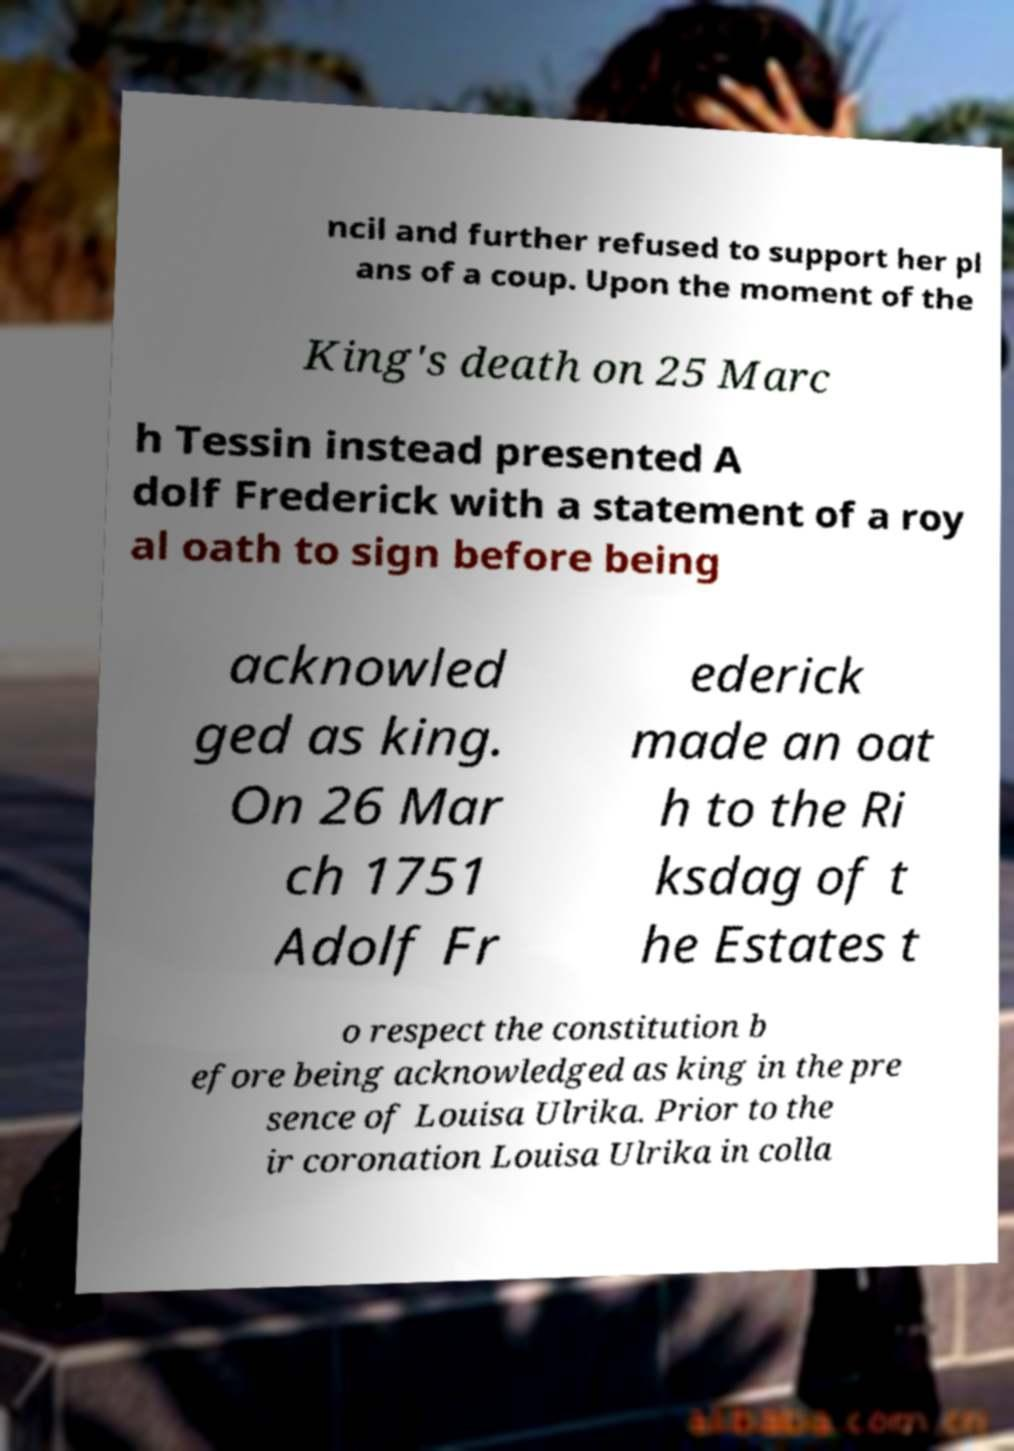I need the written content from this picture converted into text. Can you do that? ncil and further refused to support her pl ans of a coup. Upon the moment of the King's death on 25 Marc h Tessin instead presented A dolf Frederick with a statement of a roy al oath to sign before being acknowled ged as king. On 26 Mar ch 1751 Adolf Fr ederick made an oat h to the Ri ksdag of t he Estates t o respect the constitution b efore being acknowledged as king in the pre sence of Louisa Ulrika. Prior to the ir coronation Louisa Ulrika in colla 